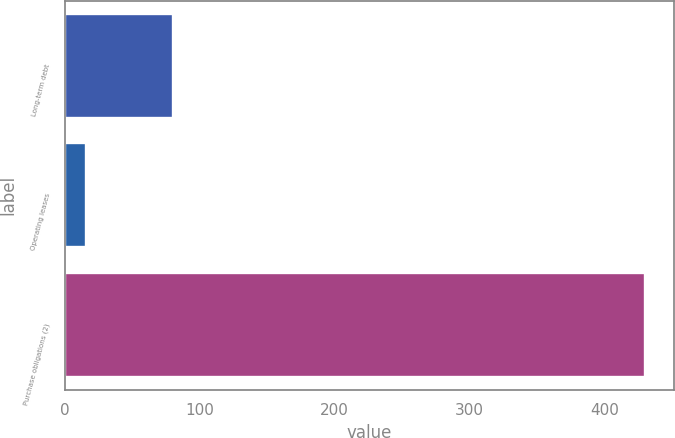Convert chart. <chart><loc_0><loc_0><loc_500><loc_500><bar_chart><fcel>Long-term debt<fcel>Operating leases<fcel>Purchase obligations (2)<nl><fcel>80<fcel>16<fcel>430<nl></chart> 